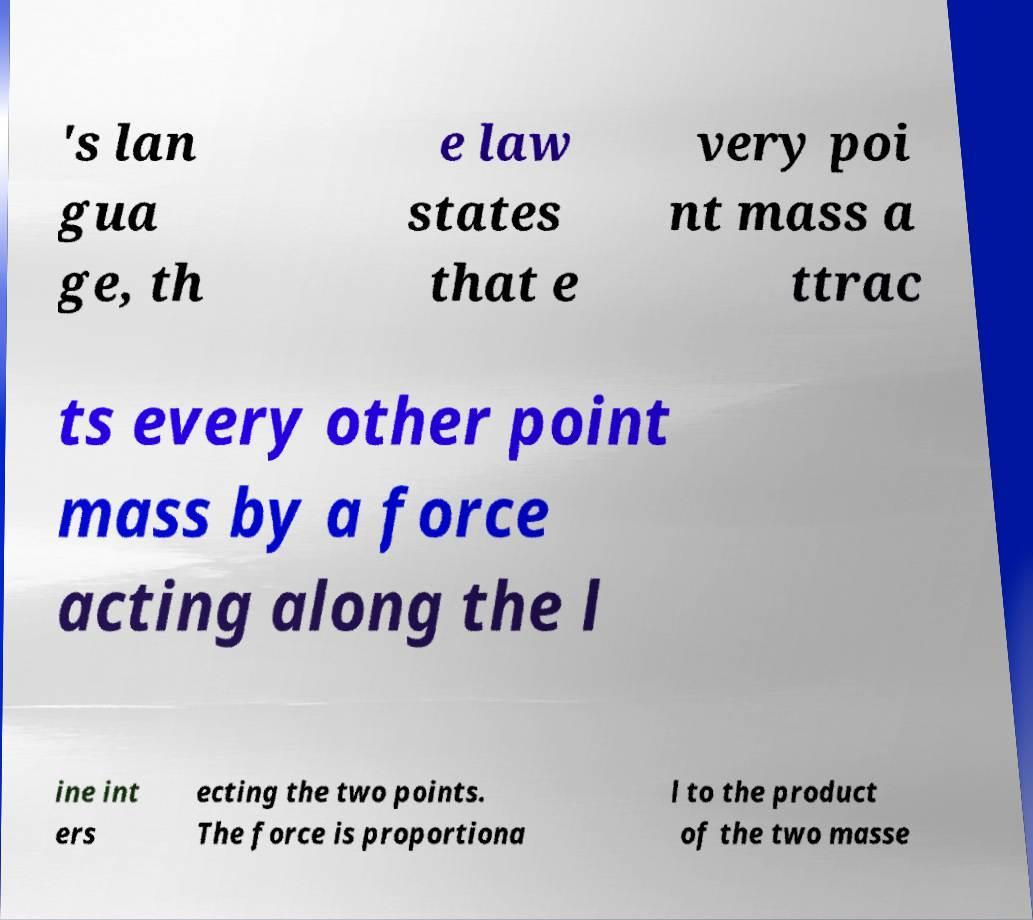What messages or text are displayed in this image? I need them in a readable, typed format. 's lan gua ge, th e law states that e very poi nt mass a ttrac ts every other point mass by a force acting along the l ine int ers ecting the two points. The force is proportiona l to the product of the two masse 